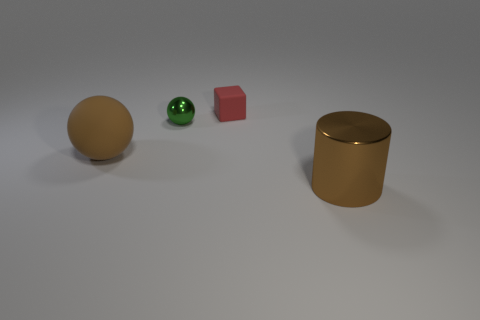How many things are either matte objects that are in front of the small matte cube or tiny things that are to the right of the tiny green shiny ball?
Offer a terse response. 2. How many other matte cubes have the same color as the matte cube?
Provide a succinct answer. 0. The big thing that is the same shape as the tiny green metal thing is what color?
Your response must be concise. Brown. There is a object that is in front of the tiny green ball and left of the small red thing; what is its shape?
Offer a very short reply. Sphere. Are there more brown metallic objects than large yellow rubber spheres?
Your answer should be compact. Yes. What material is the tiny green thing?
Your response must be concise. Metal. Is there any other thing that is the same size as the cylinder?
Your answer should be compact. Yes. What is the size of the other object that is the same shape as the big brown matte object?
Your answer should be compact. Small. Are there any tiny green metal things on the left side of the large thing right of the tiny metal sphere?
Keep it short and to the point. Yes. Does the metal sphere have the same color as the cylinder?
Ensure brevity in your answer.  No. 